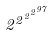<formula> <loc_0><loc_0><loc_500><loc_500>2 ^ { 2 ^ { 2 ^ { 2 ^ { 9 7 } } } }</formula> 